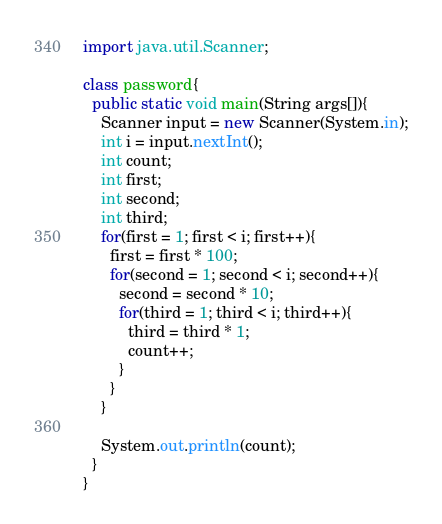<code> <loc_0><loc_0><loc_500><loc_500><_Java_>import java.util.Scanner;

class password{
  public static void main(String args[]){
    Scanner input = new Scanner(System.in);
    int i = input.nextInt();
    int count;
    int first;
    int second;
    int third;
    for(first = 1; first < i; first++){
      first = first * 100;
      for(second = 1; second < i; second++){
        second = second * 10;
        for(third = 1; third < i; third++){
          third = third * 1;
          count++;
        }
      }
    }
    
    System.out.println(count);
  }
}
</code> 